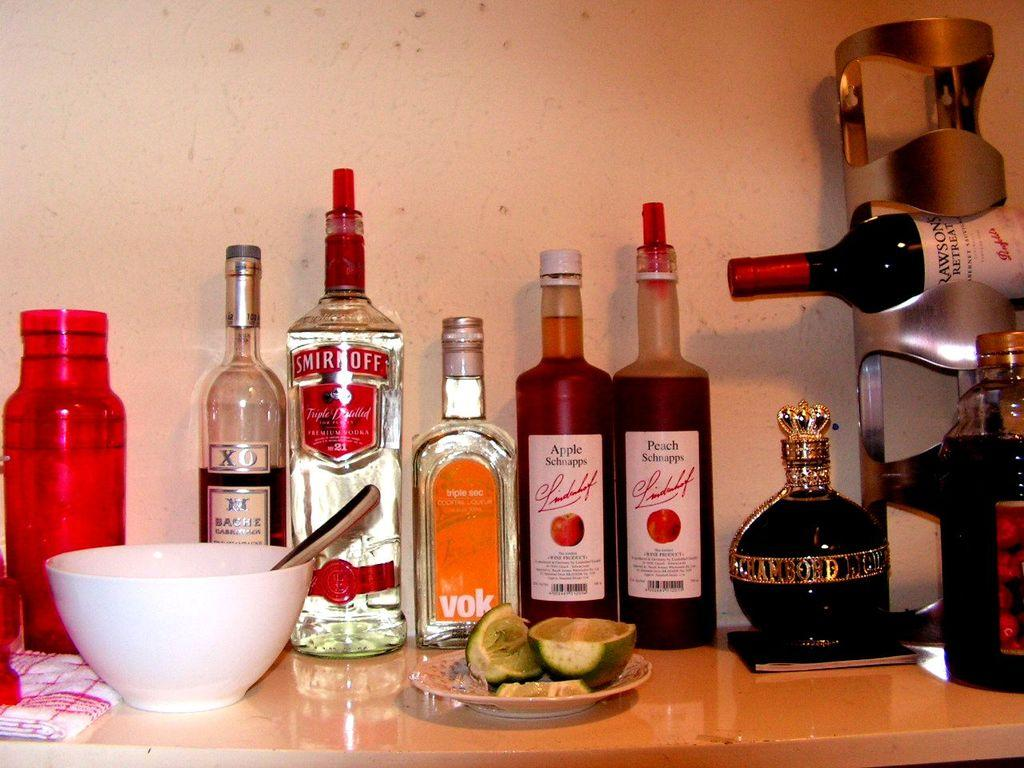<image>
Write a terse but informative summary of the picture. A few bottles of liquors in a row on a table which one of the bottles is Smirnoff, 